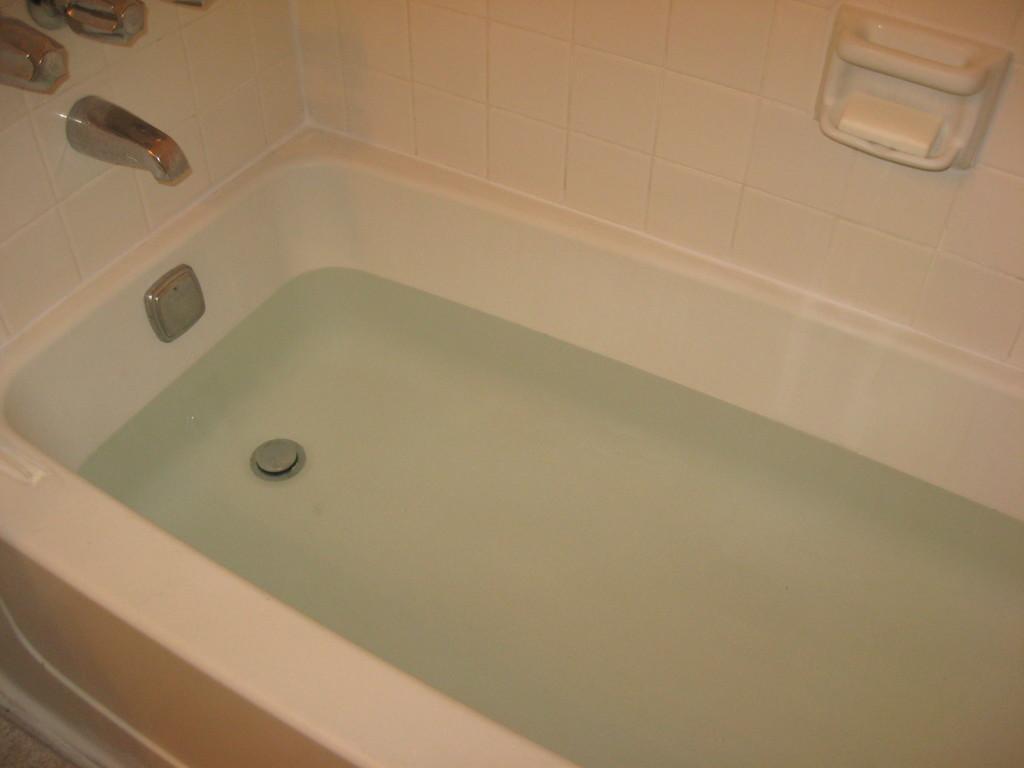Could you give a brief overview of what you see in this image? Bathtub with water. Wall with tiles. Here we can see tap and soap holder.  